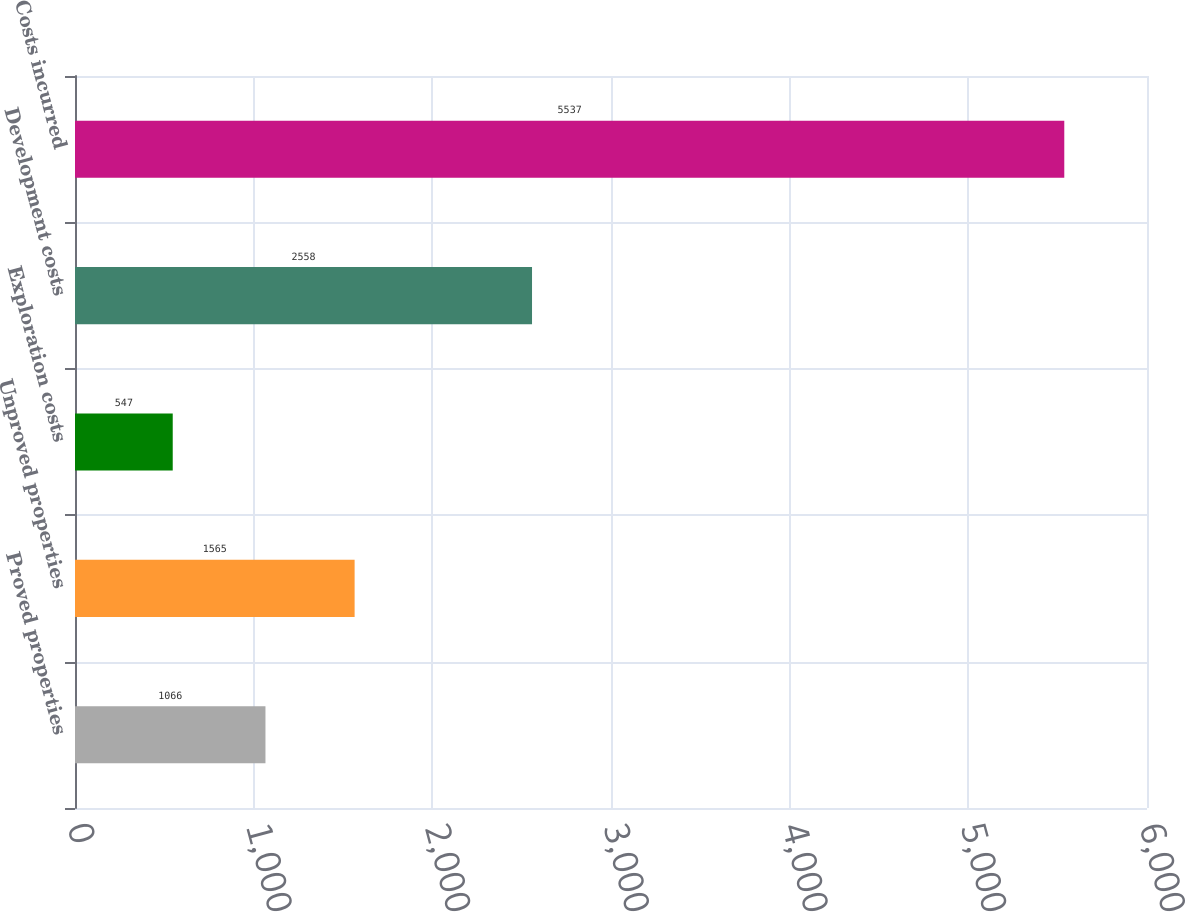<chart> <loc_0><loc_0><loc_500><loc_500><bar_chart><fcel>Proved properties<fcel>Unproved properties<fcel>Exploration costs<fcel>Development costs<fcel>Costs incurred<nl><fcel>1066<fcel>1565<fcel>547<fcel>2558<fcel>5537<nl></chart> 